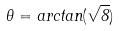Convert formula to latex. <formula><loc_0><loc_0><loc_500><loc_500>\theta = a r c t a n ( \sqrt { 8 } )</formula> 